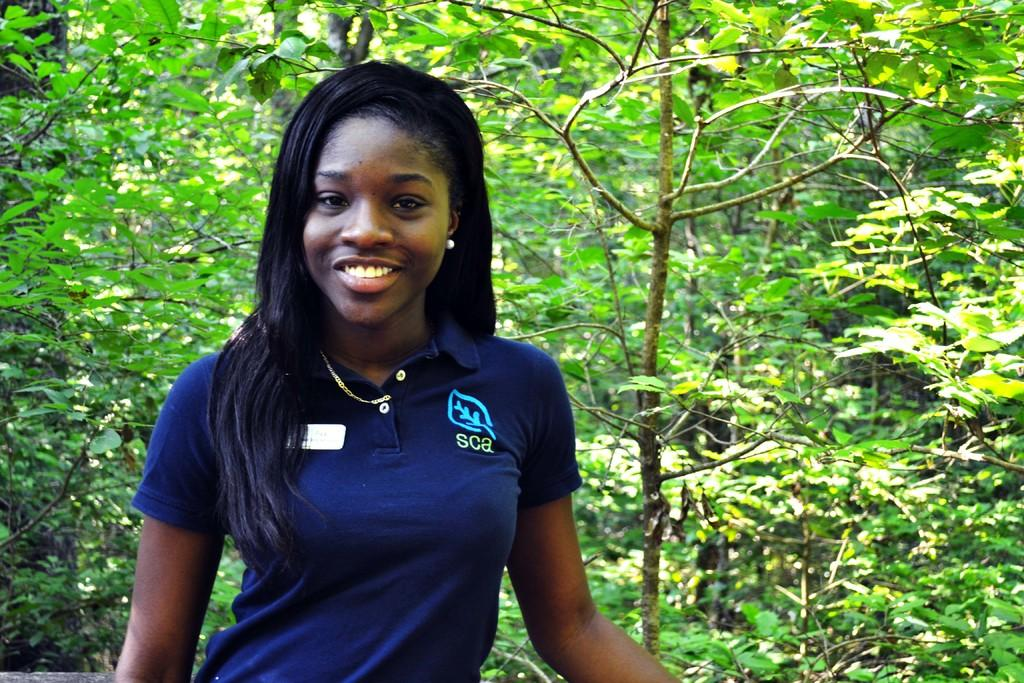Who is present in the image? There is a woman in the image. What can be seen in the background of the image? There are trees surrounding the woman in the image. Can you tell me how many visitors are present in the image? There is no mention of visitors in the image; it only features a woman and trees. What type of arch can be seen in the image? There is no arch present in the image. 